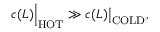<formula> <loc_0><loc_0><loc_500><loc_500>c ( L ) \left | _ { H O T } \gg c ( L ) \right | _ { C O L D } ,</formula> 